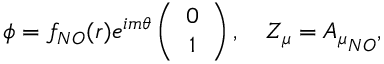Convert formula to latex. <formula><loc_0><loc_0><loc_500><loc_500>\phi = f _ { N O } ( r ) e ^ { i m \theta } \left ( \begin{array} { c } { 0 } \\ { 1 } \end{array} \right ) , \quad Z _ { \mu } = { A _ { \mu } } _ { N O } ,</formula> 